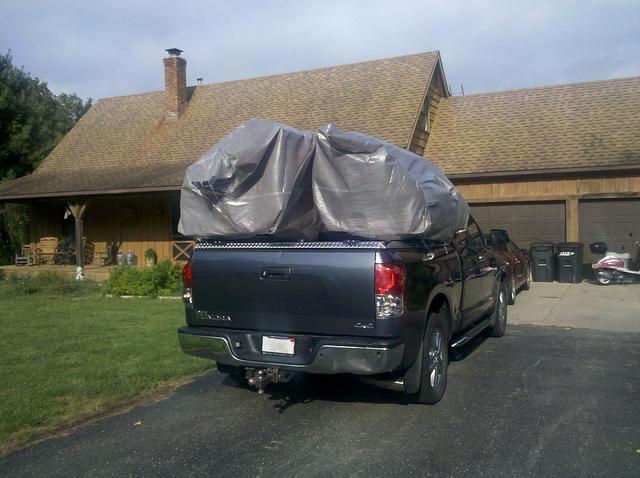How many people are wearing pink shirt?
Give a very brief answer. 0. 